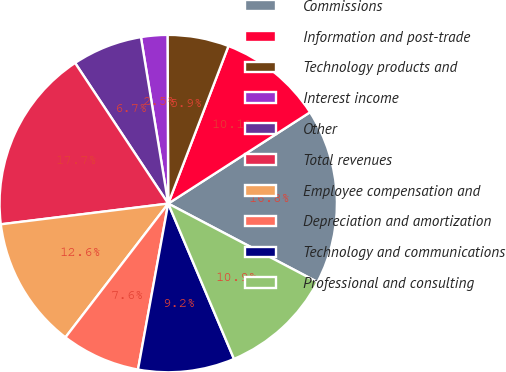<chart> <loc_0><loc_0><loc_500><loc_500><pie_chart><fcel>Commissions<fcel>Information and post-trade<fcel>Technology products and<fcel>Interest income<fcel>Other<fcel>Total revenues<fcel>Employee compensation and<fcel>Depreciation and amortization<fcel>Technology and communications<fcel>Professional and consulting<nl><fcel>16.81%<fcel>10.08%<fcel>5.88%<fcel>2.52%<fcel>6.72%<fcel>17.65%<fcel>12.61%<fcel>7.56%<fcel>9.24%<fcel>10.92%<nl></chart> 